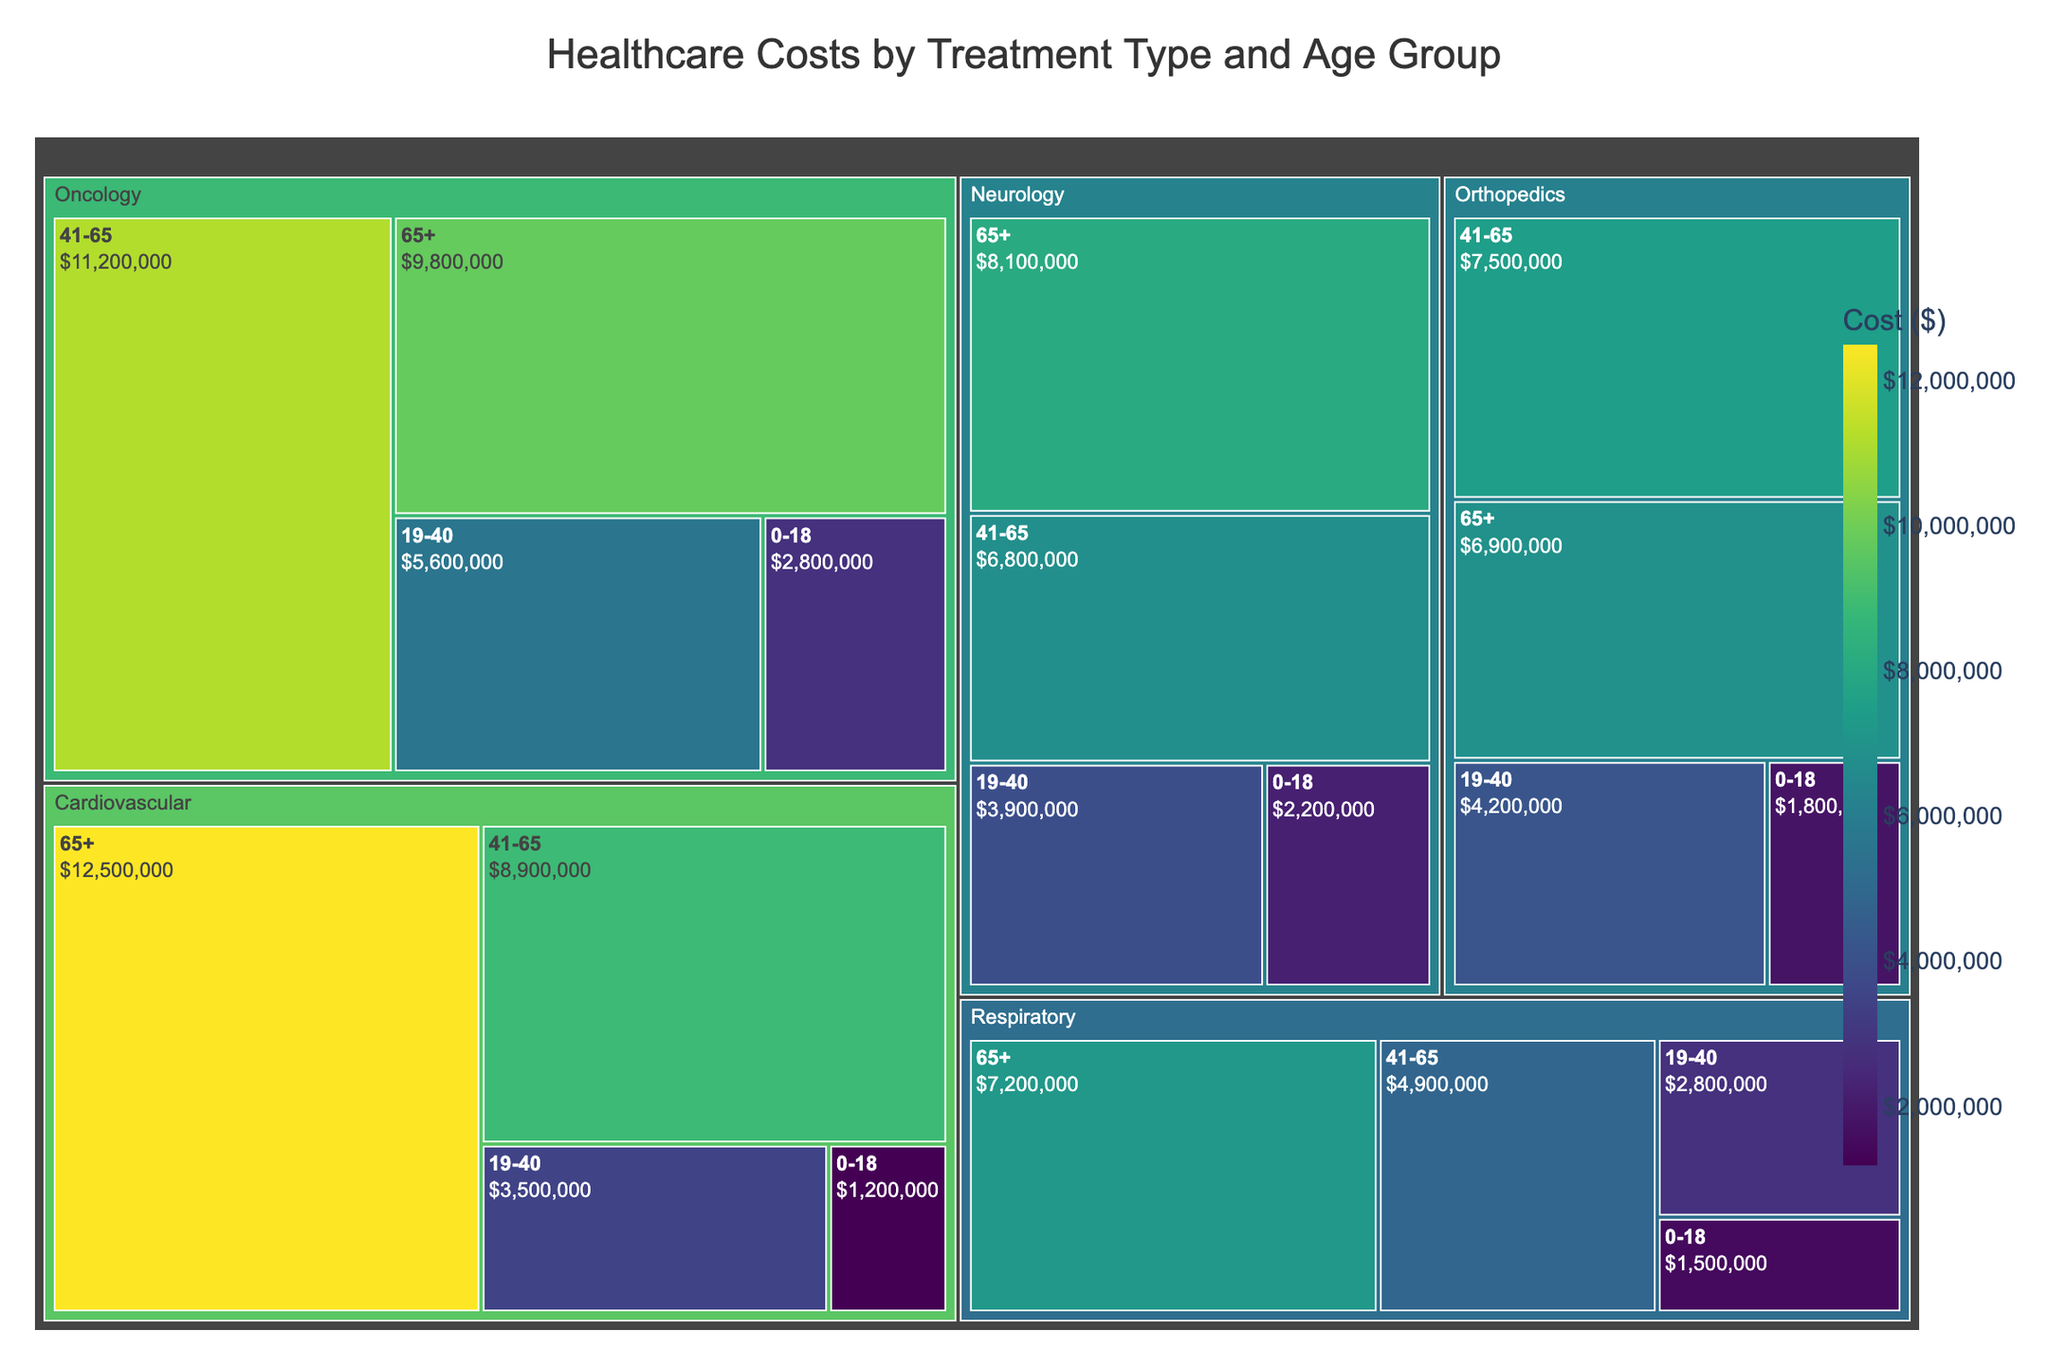What is the title of the figure? The title is usually placed at the top center of the figure and is bolded to draw attention. By looking at the top of the figure, we see the title reads "Healthcare Costs by Treatment Type and Age Group."
Answer: Healthcare Costs by Treatment Type and Age Group Which treatment type has the highest total cost? In a treemap, each rectangle's size represents the magnitude of the cost. The treatment type with the largest rectangle overall includes all age groups. By observing the figure, we can see that the largest area belongs to Cardiovascular.
Answer: Cardiovascular What is the cost of Cardiovascular treatments for the 41-65 age group? By locating the Cardiovascular section in the treemap and then finding the 41-65 age group within that section, the cost can be directly read off the figure. The figure shows the cost as $8,900,000.
Answer: $8,900,000 Which age group within Oncology has the lowest cost and what is that cost? In the Oncology section, the size of the rectangles represents the costs for each age group. By identifying the smallest rectangle within Oncology, we find it corresponds to the 0-18 age group, with a cost of $2,800,000.
Answer: 0-18, $2,800,000 Compare the costs of Neurology treatments for age groups 19-40 and 65+. Which group has higher costs and by how much? First, locate the Neurology section and then the 19-40 and 65+ age groups. The costs for these groups are $3,900,000 and $8,100,000, respectively. Subtracting the smaller cost from the larger gives $8,100,000 - $3,900,000 = $4,200,000.
Answer: 65+, $4,200,000 What is the total cost for Orthopedics treatments across all age groups? To find the total, add the costs for all age groups within Orthopedics. This includes $1,800,000 (0-18) + $4,200,000 (19-40) + $7,500,000 (41-65) + $6,900,000 (65+). The total sum is $20,400,000.
Answer: $20,400,000 Which treatment type and age group combination has the highest cost? In the treemap, the combination with the largest individual rectangle corresponds to the highest cost. Observing the rectangles, the Cardiovascular treatments for 65+ age group has the largest rectangle with a cost of $12,500,000.
Answer: Cardiovascular, 65+, $12,500,000 Find the average cost of Respiratory treatments across all age groups. Sum the cost of Respiratory treatments for all age groups and divide by the number of age groups. This is calculated as ($1,500,000 + $2,800,000 + $4,900,000 + $7,200,000)/4. The total is $16,400,000 and the average is $16,400,000/4 = $4,100,000.
Answer: $4,100,000 